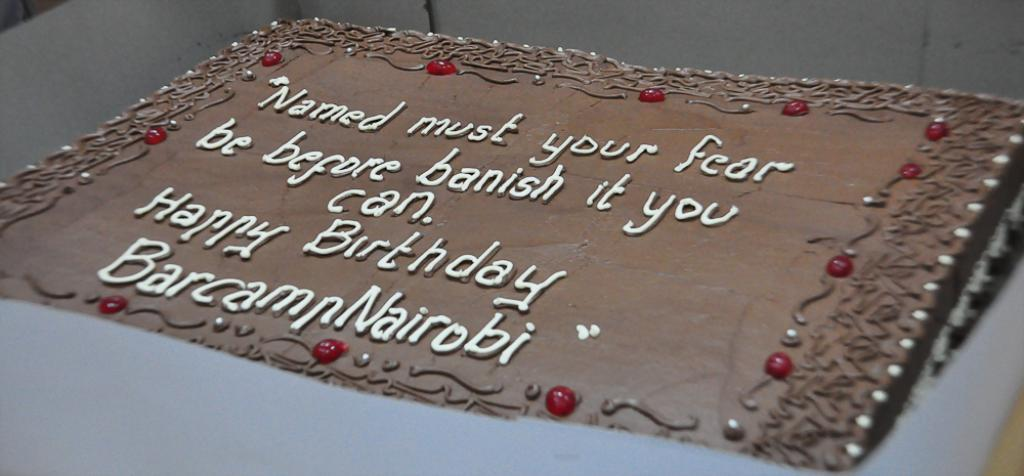What is the main subject of the image? The main subject of the image is a cake. How is the cake being stored or transported? The cake is placed in a box. What decorative elements are on the cake? There are cherries on the cake. Where is the faucet located in the image? There is no faucet present in the image. Who is the creator of the cake in the image? The creator of the cake is not mentioned in the image. 